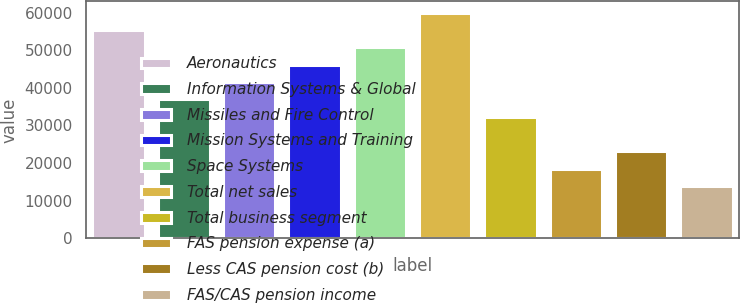<chart> <loc_0><loc_0><loc_500><loc_500><bar_chart><fcel>Aeronautics<fcel>Information Systems & Global<fcel>Missiles and Fire Control<fcel>Mission Systems and Training<fcel>Space Systems<fcel>Total net sales<fcel>Total business segment<fcel>FAS pension expense (a)<fcel>Less CAS pension cost (b)<fcel>FAS/CAS pension income<nl><fcel>55348.4<fcel>36915.6<fcel>41523.8<fcel>46132<fcel>50740.2<fcel>59956.6<fcel>32307.4<fcel>18482.8<fcel>23091<fcel>13874.6<nl></chart> 